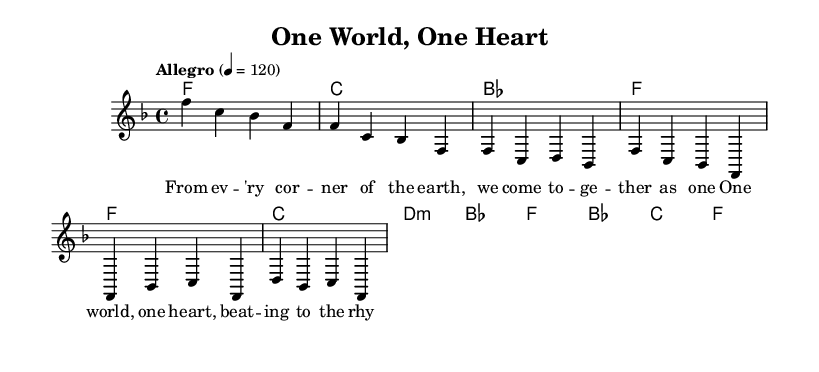What is the key signature of this music? The key signature is F major, which has one flat (B flat). This can be seen in the key signature marking at the beginning of the staff.
Answer: F major What is the time signature of this piece? The time signature is 4/4, indicating that there are four beats per measure and the quarter note gets one beat. This is specified at the beginning of the score.
Answer: 4/4 What is the tempo marking for this piece? The tempo marking is "Allegro" with a metronome marking of 120 beats per minute, indicating a fast and lively tempo. This is shown in the tempo indication at the beginning.
Answer: Allegro 120 How many measures are in the verse section? There are four measures in the verse section, as indicated by the number of brackets and the sequence of notes shown in the melody line for that section.
Answer: 4 What is the primary theme of this song as reflected in the lyrics? The primary theme is unity and love, as highlighted in the lyrics which mention coming together and the rhythm of love. This theme can be gleaned from the phrases in the lyric mode of the song.
Answer: Unity and love Which musical element is emphasized during the chorus? The harmony is emphasized during the chorus, showcasing the transition from the verse and creating a fuller sound as noted by the chords used and their arrangement alongside the lyrics.
Answer: Harmony 